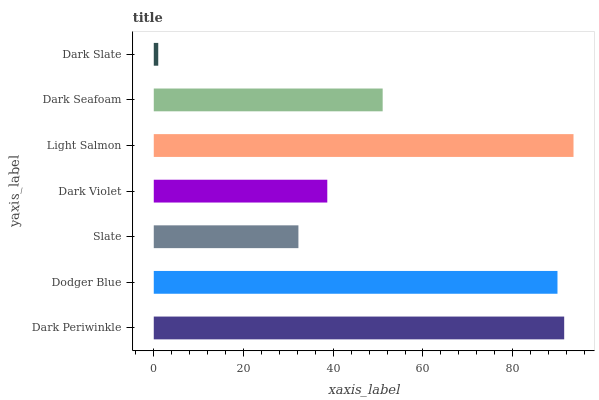Is Dark Slate the minimum?
Answer yes or no. Yes. Is Light Salmon the maximum?
Answer yes or no. Yes. Is Dodger Blue the minimum?
Answer yes or no. No. Is Dodger Blue the maximum?
Answer yes or no. No. Is Dark Periwinkle greater than Dodger Blue?
Answer yes or no. Yes. Is Dodger Blue less than Dark Periwinkle?
Answer yes or no. Yes. Is Dodger Blue greater than Dark Periwinkle?
Answer yes or no. No. Is Dark Periwinkle less than Dodger Blue?
Answer yes or no. No. Is Dark Seafoam the high median?
Answer yes or no. Yes. Is Dark Seafoam the low median?
Answer yes or no. Yes. Is Slate the high median?
Answer yes or no. No. Is Dark Violet the low median?
Answer yes or no. No. 